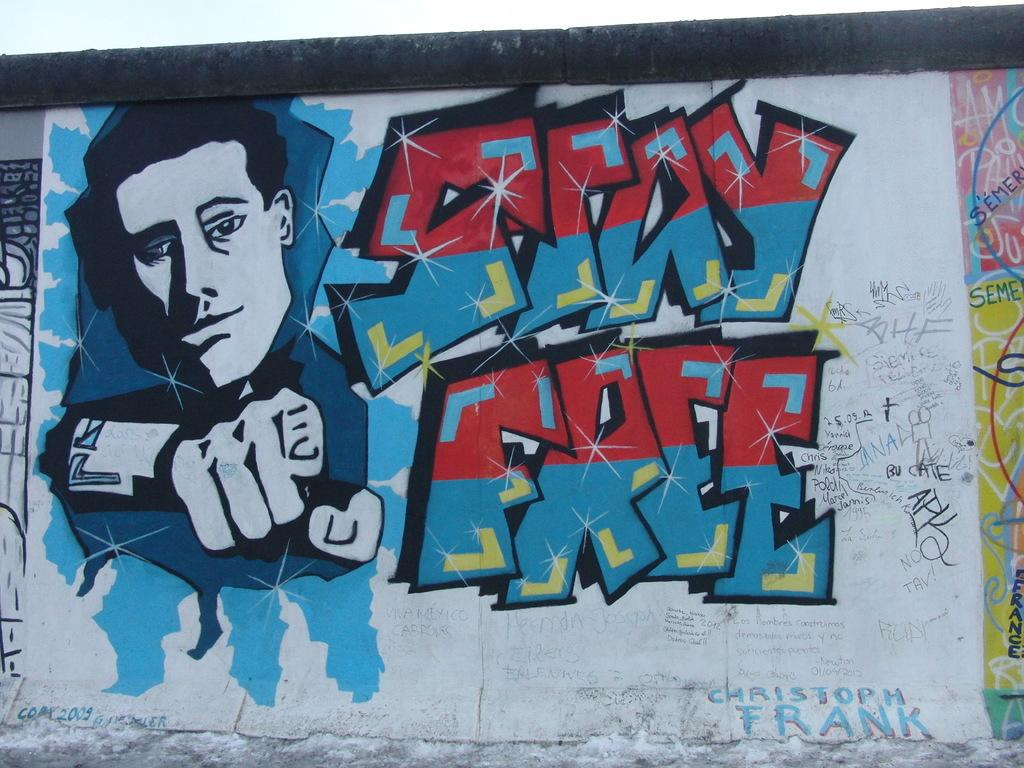<image>
Offer a succinct explanation of the picture presented. A graffiti artist painted this, it says STAY FREE with a man pointing at the viewer and has the name CHRISTOPH FRANK on the lower right hand side. 